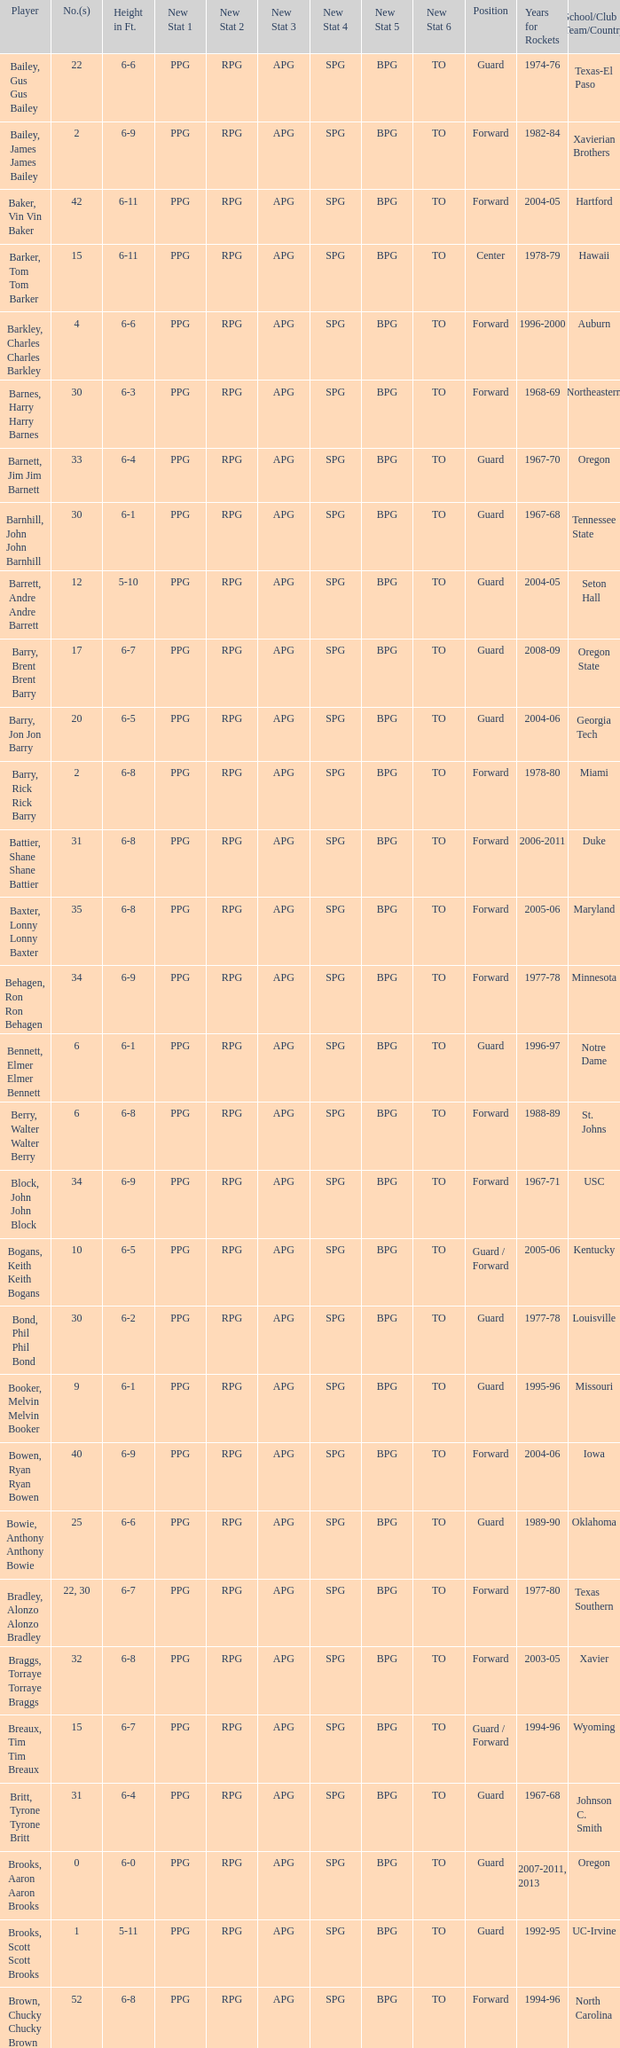What school did the forward whose number is 10 belong to? Arizona. 